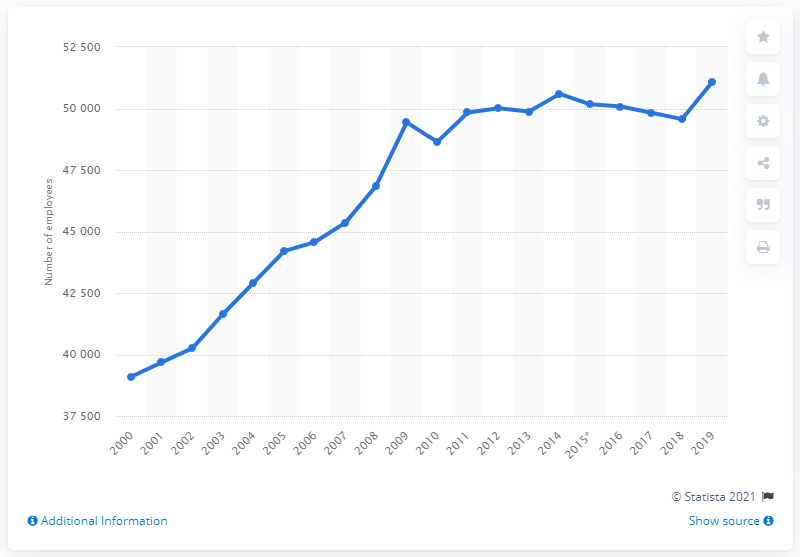Outline some significant characteristics in this image. In 2019, there were 51,096 general practitioners in the United Kingdom. 